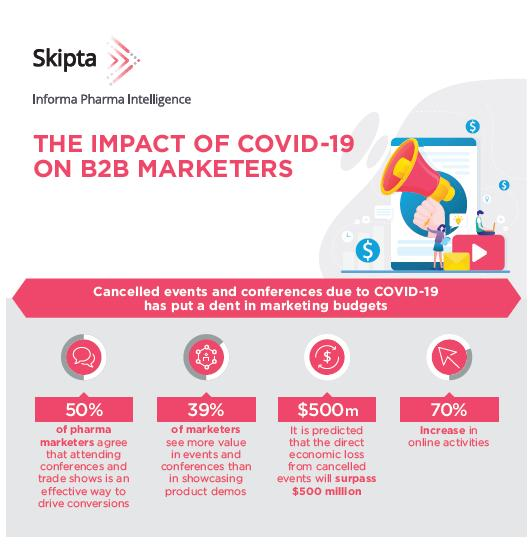Highlight a few significant elements in this photo. During the COVID-19 pandemic, 39% of B2B marketers reported that they believe events and conferences offer more value than product demos. During the COVID-19 pandemic, there has been a significant increase in online activities, with a reported 70% increase. 